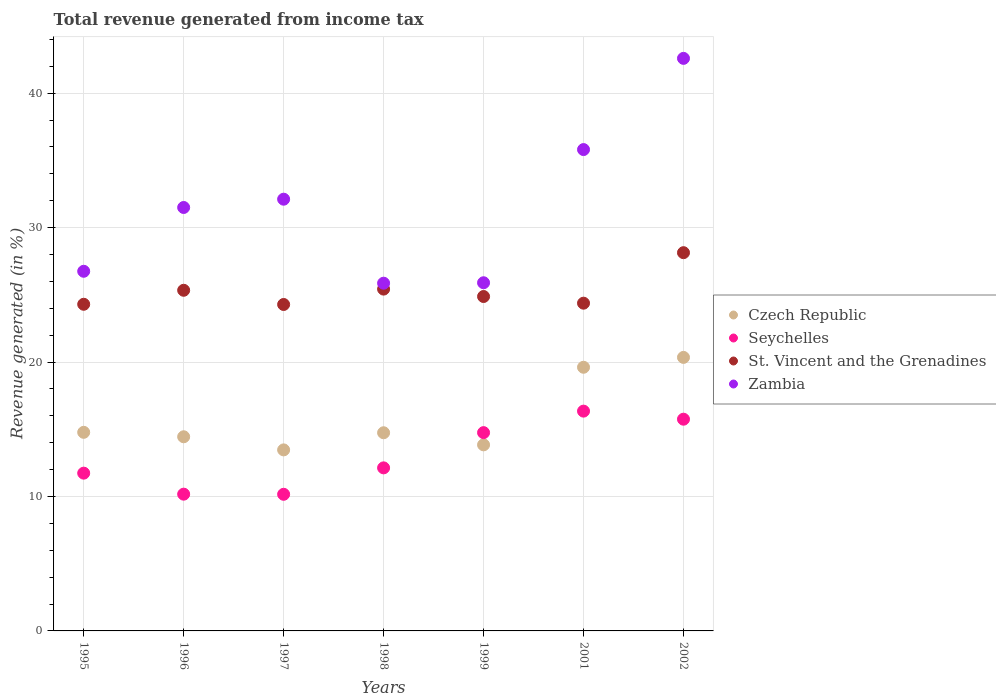Is the number of dotlines equal to the number of legend labels?
Your response must be concise. Yes. What is the total revenue generated in Seychelles in 1997?
Your response must be concise. 10.16. Across all years, what is the maximum total revenue generated in St. Vincent and the Grenadines?
Provide a succinct answer. 28.14. Across all years, what is the minimum total revenue generated in Czech Republic?
Provide a short and direct response. 13.47. In which year was the total revenue generated in Czech Republic minimum?
Your response must be concise. 1997. What is the total total revenue generated in Czech Republic in the graph?
Offer a very short reply. 111.23. What is the difference between the total revenue generated in Zambia in 1996 and that in 1997?
Provide a short and direct response. -0.62. What is the difference between the total revenue generated in Seychelles in 2001 and the total revenue generated in Zambia in 1996?
Make the answer very short. -15.15. What is the average total revenue generated in Seychelles per year?
Offer a very short reply. 13.01. In the year 1997, what is the difference between the total revenue generated in Seychelles and total revenue generated in Czech Republic?
Your answer should be very brief. -3.3. What is the ratio of the total revenue generated in Czech Republic in 1995 to that in 1996?
Your answer should be very brief. 1.02. What is the difference between the highest and the second highest total revenue generated in Seychelles?
Offer a very short reply. 0.6. What is the difference between the highest and the lowest total revenue generated in Zambia?
Offer a terse response. 16.72. In how many years, is the total revenue generated in Zambia greater than the average total revenue generated in Zambia taken over all years?
Your response must be concise. 3. Is it the case that in every year, the sum of the total revenue generated in St. Vincent and the Grenadines and total revenue generated in Seychelles  is greater than the sum of total revenue generated in Czech Republic and total revenue generated in Zambia?
Your response must be concise. Yes. Is it the case that in every year, the sum of the total revenue generated in St. Vincent and the Grenadines and total revenue generated in Czech Republic  is greater than the total revenue generated in Zambia?
Offer a terse response. Yes. Is the total revenue generated in St. Vincent and the Grenadines strictly greater than the total revenue generated in Seychelles over the years?
Your answer should be compact. Yes. Is the total revenue generated in Seychelles strictly less than the total revenue generated in Czech Republic over the years?
Your answer should be very brief. No. How many dotlines are there?
Your answer should be compact. 4. How many years are there in the graph?
Your answer should be very brief. 7. Where does the legend appear in the graph?
Your answer should be very brief. Center right. How many legend labels are there?
Your answer should be compact. 4. What is the title of the graph?
Provide a short and direct response. Total revenue generated from income tax. Does "Andorra" appear as one of the legend labels in the graph?
Your answer should be very brief. No. What is the label or title of the X-axis?
Offer a terse response. Years. What is the label or title of the Y-axis?
Give a very brief answer. Revenue generated (in %). What is the Revenue generated (in %) of Czech Republic in 1995?
Keep it short and to the point. 14.77. What is the Revenue generated (in %) in Seychelles in 1995?
Provide a short and direct response. 11.74. What is the Revenue generated (in %) of St. Vincent and the Grenadines in 1995?
Ensure brevity in your answer.  24.3. What is the Revenue generated (in %) in Zambia in 1995?
Offer a terse response. 26.75. What is the Revenue generated (in %) of Czech Republic in 1996?
Provide a succinct answer. 14.44. What is the Revenue generated (in %) in Seychelles in 1996?
Provide a succinct answer. 10.17. What is the Revenue generated (in %) in St. Vincent and the Grenadines in 1996?
Your answer should be very brief. 25.34. What is the Revenue generated (in %) in Zambia in 1996?
Provide a succinct answer. 31.5. What is the Revenue generated (in %) in Czech Republic in 1997?
Your answer should be compact. 13.47. What is the Revenue generated (in %) of Seychelles in 1997?
Offer a terse response. 10.16. What is the Revenue generated (in %) in St. Vincent and the Grenadines in 1997?
Ensure brevity in your answer.  24.28. What is the Revenue generated (in %) in Zambia in 1997?
Keep it short and to the point. 32.12. What is the Revenue generated (in %) in Czech Republic in 1998?
Offer a very short reply. 14.74. What is the Revenue generated (in %) of Seychelles in 1998?
Keep it short and to the point. 12.13. What is the Revenue generated (in %) of St. Vincent and the Grenadines in 1998?
Make the answer very short. 25.43. What is the Revenue generated (in %) in Zambia in 1998?
Keep it short and to the point. 25.87. What is the Revenue generated (in %) of Czech Republic in 1999?
Your answer should be compact. 13.84. What is the Revenue generated (in %) in Seychelles in 1999?
Give a very brief answer. 14.75. What is the Revenue generated (in %) of St. Vincent and the Grenadines in 1999?
Provide a succinct answer. 24.88. What is the Revenue generated (in %) of Zambia in 1999?
Your answer should be compact. 25.9. What is the Revenue generated (in %) in Czech Republic in 2001?
Offer a very short reply. 19.61. What is the Revenue generated (in %) of Seychelles in 2001?
Offer a terse response. 16.35. What is the Revenue generated (in %) of St. Vincent and the Grenadines in 2001?
Your answer should be very brief. 24.38. What is the Revenue generated (in %) in Zambia in 2001?
Provide a short and direct response. 35.81. What is the Revenue generated (in %) of Czech Republic in 2002?
Your answer should be very brief. 20.35. What is the Revenue generated (in %) in Seychelles in 2002?
Your response must be concise. 15.75. What is the Revenue generated (in %) of St. Vincent and the Grenadines in 2002?
Give a very brief answer. 28.14. What is the Revenue generated (in %) in Zambia in 2002?
Offer a very short reply. 42.59. Across all years, what is the maximum Revenue generated (in %) in Czech Republic?
Make the answer very short. 20.35. Across all years, what is the maximum Revenue generated (in %) in Seychelles?
Your answer should be compact. 16.35. Across all years, what is the maximum Revenue generated (in %) in St. Vincent and the Grenadines?
Make the answer very short. 28.14. Across all years, what is the maximum Revenue generated (in %) of Zambia?
Your response must be concise. 42.59. Across all years, what is the minimum Revenue generated (in %) of Czech Republic?
Ensure brevity in your answer.  13.47. Across all years, what is the minimum Revenue generated (in %) in Seychelles?
Your answer should be very brief. 10.16. Across all years, what is the minimum Revenue generated (in %) in St. Vincent and the Grenadines?
Your answer should be compact. 24.28. Across all years, what is the minimum Revenue generated (in %) in Zambia?
Your answer should be very brief. 25.87. What is the total Revenue generated (in %) of Czech Republic in the graph?
Keep it short and to the point. 111.23. What is the total Revenue generated (in %) of Seychelles in the graph?
Offer a very short reply. 91.05. What is the total Revenue generated (in %) in St. Vincent and the Grenadines in the graph?
Your answer should be compact. 176.74. What is the total Revenue generated (in %) of Zambia in the graph?
Offer a terse response. 220.53. What is the difference between the Revenue generated (in %) in Czech Republic in 1995 and that in 1996?
Your answer should be very brief. 0.33. What is the difference between the Revenue generated (in %) in Seychelles in 1995 and that in 1996?
Make the answer very short. 1.56. What is the difference between the Revenue generated (in %) of St. Vincent and the Grenadines in 1995 and that in 1996?
Your answer should be compact. -1.04. What is the difference between the Revenue generated (in %) of Zambia in 1995 and that in 1996?
Provide a short and direct response. -4.75. What is the difference between the Revenue generated (in %) of Czech Republic in 1995 and that in 1997?
Give a very brief answer. 1.31. What is the difference between the Revenue generated (in %) of Seychelles in 1995 and that in 1997?
Your answer should be compact. 1.57. What is the difference between the Revenue generated (in %) in St. Vincent and the Grenadines in 1995 and that in 1997?
Keep it short and to the point. 0.02. What is the difference between the Revenue generated (in %) of Zambia in 1995 and that in 1997?
Offer a terse response. -5.36. What is the difference between the Revenue generated (in %) of Czech Republic in 1995 and that in 1998?
Offer a terse response. 0.03. What is the difference between the Revenue generated (in %) in Seychelles in 1995 and that in 1998?
Your answer should be very brief. -0.39. What is the difference between the Revenue generated (in %) of St. Vincent and the Grenadines in 1995 and that in 1998?
Your answer should be very brief. -1.13. What is the difference between the Revenue generated (in %) in Zambia in 1995 and that in 1998?
Provide a short and direct response. 0.89. What is the difference between the Revenue generated (in %) of Czech Republic in 1995 and that in 1999?
Keep it short and to the point. 0.93. What is the difference between the Revenue generated (in %) in Seychelles in 1995 and that in 1999?
Keep it short and to the point. -3.01. What is the difference between the Revenue generated (in %) in St. Vincent and the Grenadines in 1995 and that in 1999?
Provide a short and direct response. -0.58. What is the difference between the Revenue generated (in %) of Zambia in 1995 and that in 1999?
Keep it short and to the point. 0.85. What is the difference between the Revenue generated (in %) in Czech Republic in 1995 and that in 2001?
Ensure brevity in your answer.  -4.84. What is the difference between the Revenue generated (in %) of Seychelles in 1995 and that in 2001?
Make the answer very short. -4.61. What is the difference between the Revenue generated (in %) in St. Vincent and the Grenadines in 1995 and that in 2001?
Ensure brevity in your answer.  -0.08. What is the difference between the Revenue generated (in %) in Zambia in 1995 and that in 2001?
Provide a short and direct response. -9.05. What is the difference between the Revenue generated (in %) of Czech Republic in 1995 and that in 2002?
Keep it short and to the point. -5.57. What is the difference between the Revenue generated (in %) of Seychelles in 1995 and that in 2002?
Ensure brevity in your answer.  -4.01. What is the difference between the Revenue generated (in %) of St. Vincent and the Grenadines in 1995 and that in 2002?
Offer a very short reply. -3.84. What is the difference between the Revenue generated (in %) in Zambia in 1995 and that in 2002?
Keep it short and to the point. -15.84. What is the difference between the Revenue generated (in %) in Czech Republic in 1996 and that in 1997?
Give a very brief answer. 0.98. What is the difference between the Revenue generated (in %) of Seychelles in 1996 and that in 1997?
Offer a terse response. 0.01. What is the difference between the Revenue generated (in %) in St. Vincent and the Grenadines in 1996 and that in 1997?
Keep it short and to the point. 1.06. What is the difference between the Revenue generated (in %) of Zambia in 1996 and that in 1997?
Offer a very short reply. -0.62. What is the difference between the Revenue generated (in %) in Czech Republic in 1996 and that in 1998?
Your response must be concise. -0.3. What is the difference between the Revenue generated (in %) of Seychelles in 1996 and that in 1998?
Offer a very short reply. -1.96. What is the difference between the Revenue generated (in %) of St. Vincent and the Grenadines in 1996 and that in 1998?
Make the answer very short. -0.09. What is the difference between the Revenue generated (in %) of Zambia in 1996 and that in 1998?
Your response must be concise. 5.63. What is the difference between the Revenue generated (in %) in Czech Republic in 1996 and that in 1999?
Offer a very short reply. 0.6. What is the difference between the Revenue generated (in %) in Seychelles in 1996 and that in 1999?
Provide a succinct answer. -4.58. What is the difference between the Revenue generated (in %) in St. Vincent and the Grenadines in 1996 and that in 1999?
Offer a terse response. 0.46. What is the difference between the Revenue generated (in %) in Zambia in 1996 and that in 1999?
Offer a terse response. 5.6. What is the difference between the Revenue generated (in %) in Czech Republic in 1996 and that in 2001?
Make the answer very short. -5.17. What is the difference between the Revenue generated (in %) of Seychelles in 1996 and that in 2001?
Provide a short and direct response. -6.18. What is the difference between the Revenue generated (in %) of St. Vincent and the Grenadines in 1996 and that in 2001?
Your response must be concise. 0.96. What is the difference between the Revenue generated (in %) of Zambia in 1996 and that in 2001?
Your answer should be very brief. -4.31. What is the difference between the Revenue generated (in %) in Czech Republic in 1996 and that in 2002?
Provide a short and direct response. -5.9. What is the difference between the Revenue generated (in %) in Seychelles in 1996 and that in 2002?
Keep it short and to the point. -5.58. What is the difference between the Revenue generated (in %) in St. Vincent and the Grenadines in 1996 and that in 2002?
Offer a very short reply. -2.8. What is the difference between the Revenue generated (in %) of Zambia in 1996 and that in 2002?
Provide a succinct answer. -11.09. What is the difference between the Revenue generated (in %) of Czech Republic in 1997 and that in 1998?
Your answer should be very brief. -1.27. What is the difference between the Revenue generated (in %) of Seychelles in 1997 and that in 1998?
Offer a very short reply. -1.97. What is the difference between the Revenue generated (in %) of St. Vincent and the Grenadines in 1997 and that in 1998?
Ensure brevity in your answer.  -1.14. What is the difference between the Revenue generated (in %) in Zambia in 1997 and that in 1998?
Your answer should be compact. 6.25. What is the difference between the Revenue generated (in %) of Czech Republic in 1997 and that in 1999?
Give a very brief answer. -0.38. What is the difference between the Revenue generated (in %) of Seychelles in 1997 and that in 1999?
Give a very brief answer. -4.59. What is the difference between the Revenue generated (in %) in St. Vincent and the Grenadines in 1997 and that in 1999?
Keep it short and to the point. -0.59. What is the difference between the Revenue generated (in %) in Zambia in 1997 and that in 1999?
Give a very brief answer. 6.22. What is the difference between the Revenue generated (in %) in Czech Republic in 1997 and that in 2001?
Offer a terse response. -6.15. What is the difference between the Revenue generated (in %) of Seychelles in 1997 and that in 2001?
Ensure brevity in your answer.  -6.19. What is the difference between the Revenue generated (in %) of St. Vincent and the Grenadines in 1997 and that in 2001?
Provide a succinct answer. -0.1. What is the difference between the Revenue generated (in %) in Zambia in 1997 and that in 2001?
Give a very brief answer. -3.69. What is the difference between the Revenue generated (in %) in Czech Republic in 1997 and that in 2002?
Your response must be concise. -6.88. What is the difference between the Revenue generated (in %) of Seychelles in 1997 and that in 2002?
Give a very brief answer. -5.59. What is the difference between the Revenue generated (in %) in St. Vincent and the Grenadines in 1997 and that in 2002?
Your answer should be very brief. -3.85. What is the difference between the Revenue generated (in %) in Zambia in 1997 and that in 2002?
Keep it short and to the point. -10.48. What is the difference between the Revenue generated (in %) of Czech Republic in 1998 and that in 1999?
Your answer should be compact. 0.9. What is the difference between the Revenue generated (in %) in Seychelles in 1998 and that in 1999?
Make the answer very short. -2.62. What is the difference between the Revenue generated (in %) of St. Vincent and the Grenadines in 1998 and that in 1999?
Your answer should be very brief. 0.55. What is the difference between the Revenue generated (in %) of Zambia in 1998 and that in 1999?
Give a very brief answer. -0.03. What is the difference between the Revenue generated (in %) in Czech Republic in 1998 and that in 2001?
Your answer should be very brief. -4.87. What is the difference between the Revenue generated (in %) in Seychelles in 1998 and that in 2001?
Give a very brief answer. -4.22. What is the difference between the Revenue generated (in %) in St. Vincent and the Grenadines in 1998 and that in 2001?
Offer a terse response. 1.05. What is the difference between the Revenue generated (in %) of Zambia in 1998 and that in 2001?
Your answer should be very brief. -9.94. What is the difference between the Revenue generated (in %) of Czech Republic in 1998 and that in 2002?
Provide a succinct answer. -5.61. What is the difference between the Revenue generated (in %) of Seychelles in 1998 and that in 2002?
Keep it short and to the point. -3.62. What is the difference between the Revenue generated (in %) of St. Vincent and the Grenadines in 1998 and that in 2002?
Offer a terse response. -2.71. What is the difference between the Revenue generated (in %) of Zambia in 1998 and that in 2002?
Your answer should be very brief. -16.72. What is the difference between the Revenue generated (in %) in Czech Republic in 1999 and that in 2001?
Offer a very short reply. -5.77. What is the difference between the Revenue generated (in %) of Seychelles in 1999 and that in 2001?
Provide a succinct answer. -1.6. What is the difference between the Revenue generated (in %) of St. Vincent and the Grenadines in 1999 and that in 2001?
Keep it short and to the point. 0.5. What is the difference between the Revenue generated (in %) of Zambia in 1999 and that in 2001?
Provide a short and direct response. -9.91. What is the difference between the Revenue generated (in %) of Czech Republic in 1999 and that in 2002?
Your response must be concise. -6.5. What is the difference between the Revenue generated (in %) in Seychelles in 1999 and that in 2002?
Provide a short and direct response. -1. What is the difference between the Revenue generated (in %) in St. Vincent and the Grenadines in 1999 and that in 2002?
Offer a terse response. -3.26. What is the difference between the Revenue generated (in %) of Zambia in 1999 and that in 2002?
Ensure brevity in your answer.  -16.69. What is the difference between the Revenue generated (in %) in Czech Republic in 2001 and that in 2002?
Your answer should be very brief. -0.73. What is the difference between the Revenue generated (in %) of Seychelles in 2001 and that in 2002?
Your answer should be very brief. 0.6. What is the difference between the Revenue generated (in %) in St. Vincent and the Grenadines in 2001 and that in 2002?
Your answer should be very brief. -3.76. What is the difference between the Revenue generated (in %) of Zambia in 2001 and that in 2002?
Offer a terse response. -6.78. What is the difference between the Revenue generated (in %) of Czech Republic in 1995 and the Revenue generated (in %) of Seychelles in 1996?
Your answer should be very brief. 4.6. What is the difference between the Revenue generated (in %) in Czech Republic in 1995 and the Revenue generated (in %) in St. Vincent and the Grenadines in 1996?
Offer a terse response. -10.57. What is the difference between the Revenue generated (in %) of Czech Republic in 1995 and the Revenue generated (in %) of Zambia in 1996?
Ensure brevity in your answer.  -16.73. What is the difference between the Revenue generated (in %) of Seychelles in 1995 and the Revenue generated (in %) of St. Vincent and the Grenadines in 1996?
Make the answer very short. -13.6. What is the difference between the Revenue generated (in %) in Seychelles in 1995 and the Revenue generated (in %) in Zambia in 1996?
Your response must be concise. -19.76. What is the difference between the Revenue generated (in %) of Czech Republic in 1995 and the Revenue generated (in %) of Seychelles in 1997?
Your response must be concise. 4.61. What is the difference between the Revenue generated (in %) of Czech Republic in 1995 and the Revenue generated (in %) of St. Vincent and the Grenadines in 1997?
Your answer should be very brief. -9.51. What is the difference between the Revenue generated (in %) in Czech Republic in 1995 and the Revenue generated (in %) in Zambia in 1997?
Offer a very short reply. -17.34. What is the difference between the Revenue generated (in %) in Seychelles in 1995 and the Revenue generated (in %) in St. Vincent and the Grenadines in 1997?
Ensure brevity in your answer.  -12.55. What is the difference between the Revenue generated (in %) in Seychelles in 1995 and the Revenue generated (in %) in Zambia in 1997?
Your answer should be very brief. -20.38. What is the difference between the Revenue generated (in %) of St. Vincent and the Grenadines in 1995 and the Revenue generated (in %) of Zambia in 1997?
Make the answer very short. -7.82. What is the difference between the Revenue generated (in %) of Czech Republic in 1995 and the Revenue generated (in %) of Seychelles in 1998?
Provide a short and direct response. 2.64. What is the difference between the Revenue generated (in %) in Czech Republic in 1995 and the Revenue generated (in %) in St. Vincent and the Grenadines in 1998?
Offer a terse response. -10.65. What is the difference between the Revenue generated (in %) in Czech Republic in 1995 and the Revenue generated (in %) in Zambia in 1998?
Your response must be concise. -11.09. What is the difference between the Revenue generated (in %) of Seychelles in 1995 and the Revenue generated (in %) of St. Vincent and the Grenadines in 1998?
Offer a terse response. -13.69. What is the difference between the Revenue generated (in %) of Seychelles in 1995 and the Revenue generated (in %) of Zambia in 1998?
Your response must be concise. -14.13. What is the difference between the Revenue generated (in %) of St. Vincent and the Grenadines in 1995 and the Revenue generated (in %) of Zambia in 1998?
Make the answer very short. -1.57. What is the difference between the Revenue generated (in %) of Czech Republic in 1995 and the Revenue generated (in %) of Seychelles in 1999?
Ensure brevity in your answer.  0.02. What is the difference between the Revenue generated (in %) in Czech Republic in 1995 and the Revenue generated (in %) in St. Vincent and the Grenadines in 1999?
Ensure brevity in your answer.  -10.1. What is the difference between the Revenue generated (in %) in Czech Republic in 1995 and the Revenue generated (in %) in Zambia in 1999?
Provide a short and direct response. -11.13. What is the difference between the Revenue generated (in %) in Seychelles in 1995 and the Revenue generated (in %) in St. Vincent and the Grenadines in 1999?
Offer a terse response. -13.14. What is the difference between the Revenue generated (in %) of Seychelles in 1995 and the Revenue generated (in %) of Zambia in 1999?
Offer a terse response. -14.16. What is the difference between the Revenue generated (in %) in St. Vincent and the Grenadines in 1995 and the Revenue generated (in %) in Zambia in 1999?
Provide a succinct answer. -1.6. What is the difference between the Revenue generated (in %) of Czech Republic in 1995 and the Revenue generated (in %) of Seychelles in 2001?
Ensure brevity in your answer.  -1.58. What is the difference between the Revenue generated (in %) in Czech Republic in 1995 and the Revenue generated (in %) in St. Vincent and the Grenadines in 2001?
Give a very brief answer. -9.61. What is the difference between the Revenue generated (in %) in Czech Republic in 1995 and the Revenue generated (in %) in Zambia in 2001?
Give a very brief answer. -21.03. What is the difference between the Revenue generated (in %) of Seychelles in 1995 and the Revenue generated (in %) of St. Vincent and the Grenadines in 2001?
Provide a succinct answer. -12.64. What is the difference between the Revenue generated (in %) of Seychelles in 1995 and the Revenue generated (in %) of Zambia in 2001?
Your answer should be compact. -24.07. What is the difference between the Revenue generated (in %) in St. Vincent and the Grenadines in 1995 and the Revenue generated (in %) in Zambia in 2001?
Offer a very short reply. -11.51. What is the difference between the Revenue generated (in %) in Czech Republic in 1995 and the Revenue generated (in %) in Seychelles in 2002?
Your response must be concise. -0.98. What is the difference between the Revenue generated (in %) in Czech Republic in 1995 and the Revenue generated (in %) in St. Vincent and the Grenadines in 2002?
Your answer should be very brief. -13.36. What is the difference between the Revenue generated (in %) of Czech Republic in 1995 and the Revenue generated (in %) of Zambia in 2002?
Provide a succinct answer. -27.82. What is the difference between the Revenue generated (in %) of Seychelles in 1995 and the Revenue generated (in %) of St. Vincent and the Grenadines in 2002?
Give a very brief answer. -16.4. What is the difference between the Revenue generated (in %) of Seychelles in 1995 and the Revenue generated (in %) of Zambia in 2002?
Provide a succinct answer. -30.86. What is the difference between the Revenue generated (in %) in St. Vincent and the Grenadines in 1995 and the Revenue generated (in %) in Zambia in 2002?
Your answer should be very brief. -18.29. What is the difference between the Revenue generated (in %) of Czech Republic in 1996 and the Revenue generated (in %) of Seychelles in 1997?
Give a very brief answer. 4.28. What is the difference between the Revenue generated (in %) in Czech Republic in 1996 and the Revenue generated (in %) in St. Vincent and the Grenadines in 1997?
Provide a succinct answer. -9.84. What is the difference between the Revenue generated (in %) in Czech Republic in 1996 and the Revenue generated (in %) in Zambia in 1997?
Provide a succinct answer. -17.67. What is the difference between the Revenue generated (in %) in Seychelles in 1996 and the Revenue generated (in %) in St. Vincent and the Grenadines in 1997?
Offer a very short reply. -14.11. What is the difference between the Revenue generated (in %) of Seychelles in 1996 and the Revenue generated (in %) of Zambia in 1997?
Keep it short and to the point. -21.94. What is the difference between the Revenue generated (in %) of St. Vincent and the Grenadines in 1996 and the Revenue generated (in %) of Zambia in 1997?
Your response must be concise. -6.78. What is the difference between the Revenue generated (in %) in Czech Republic in 1996 and the Revenue generated (in %) in Seychelles in 1998?
Provide a succinct answer. 2.31. What is the difference between the Revenue generated (in %) in Czech Republic in 1996 and the Revenue generated (in %) in St. Vincent and the Grenadines in 1998?
Make the answer very short. -10.98. What is the difference between the Revenue generated (in %) in Czech Republic in 1996 and the Revenue generated (in %) in Zambia in 1998?
Your answer should be compact. -11.42. What is the difference between the Revenue generated (in %) in Seychelles in 1996 and the Revenue generated (in %) in St. Vincent and the Grenadines in 1998?
Your answer should be compact. -15.25. What is the difference between the Revenue generated (in %) of Seychelles in 1996 and the Revenue generated (in %) of Zambia in 1998?
Your answer should be very brief. -15.69. What is the difference between the Revenue generated (in %) in St. Vincent and the Grenadines in 1996 and the Revenue generated (in %) in Zambia in 1998?
Give a very brief answer. -0.53. What is the difference between the Revenue generated (in %) of Czech Republic in 1996 and the Revenue generated (in %) of Seychelles in 1999?
Offer a very short reply. -0.31. What is the difference between the Revenue generated (in %) in Czech Republic in 1996 and the Revenue generated (in %) in St. Vincent and the Grenadines in 1999?
Your response must be concise. -10.43. What is the difference between the Revenue generated (in %) in Czech Republic in 1996 and the Revenue generated (in %) in Zambia in 1999?
Your answer should be compact. -11.46. What is the difference between the Revenue generated (in %) of Seychelles in 1996 and the Revenue generated (in %) of St. Vincent and the Grenadines in 1999?
Offer a very short reply. -14.7. What is the difference between the Revenue generated (in %) of Seychelles in 1996 and the Revenue generated (in %) of Zambia in 1999?
Offer a very short reply. -15.73. What is the difference between the Revenue generated (in %) of St. Vincent and the Grenadines in 1996 and the Revenue generated (in %) of Zambia in 1999?
Give a very brief answer. -0.56. What is the difference between the Revenue generated (in %) in Czech Republic in 1996 and the Revenue generated (in %) in Seychelles in 2001?
Make the answer very short. -1.91. What is the difference between the Revenue generated (in %) of Czech Republic in 1996 and the Revenue generated (in %) of St. Vincent and the Grenadines in 2001?
Provide a succinct answer. -9.94. What is the difference between the Revenue generated (in %) in Czech Republic in 1996 and the Revenue generated (in %) in Zambia in 2001?
Your answer should be compact. -21.36. What is the difference between the Revenue generated (in %) of Seychelles in 1996 and the Revenue generated (in %) of St. Vincent and the Grenadines in 2001?
Keep it short and to the point. -14.21. What is the difference between the Revenue generated (in %) of Seychelles in 1996 and the Revenue generated (in %) of Zambia in 2001?
Provide a short and direct response. -25.63. What is the difference between the Revenue generated (in %) in St. Vincent and the Grenadines in 1996 and the Revenue generated (in %) in Zambia in 2001?
Offer a terse response. -10.47. What is the difference between the Revenue generated (in %) in Czech Republic in 1996 and the Revenue generated (in %) in Seychelles in 2002?
Your response must be concise. -1.31. What is the difference between the Revenue generated (in %) of Czech Republic in 1996 and the Revenue generated (in %) of St. Vincent and the Grenadines in 2002?
Give a very brief answer. -13.69. What is the difference between the Revenue generated (in %) of Czech Republic in 1996 and the Revenue generated (in %) of Zambia in 2002?
Your response must be concise. -28.15. What is the difference between the Revenue generated (in %) of Seychelles in 1996 and the Revenue generated (in %) of St. Vincent and the Grenadines in 2002?
Provide a short and direct response. -17.96. What is the difference between the Revenue generated (in %) of Seychelles in 1996 and the Revenue generated (in %) of Zambia in 2002?
Provide a short and direct response. -32.42. What is the difference between the Revenue generated (in %) in St. Vincent and the Grenadines in 1996 and the Revenue generated (in %) in Zambia in 2002?
Your answer should be very brief. -17.25. What is the difference between the Revenue generated (in %) in Czech Republic in 1997 and the Revenue generated (in %) in Seychelles in 1998?
Provide a succinct answer. 1.34. What is the difference between the Revenue generated (in %) of Czech Republic in 1997 and the Revenue generated (in %) of St. Vincent and the Grenadines in 1998?
Offer a very short reply. -11.96. What is the difference between the Revenue generated (in %) of Czech Republic in 1997 and the Revenue generated (in %) of Zambia in 1998?
Ensure brevity in your answer.  -12.4. What is the difference between the Revenue generated (in %) in Seychelles in 1997 and the Revenue generated (in %) in St. Vincent and the Grenadines in 1998?
Offer a very short reply. -15.26. What is the difference between the Revenue generated (in %) in Seychelles in 1997 and the Revenue generated (in %) in Zambia in 1998?
Your response must be concise. -15.7. What is the difference between the Revenue generated (in %) in St. Vincent and the Grenadines in 1997 and the Revenue generated (in %) in Zambia in 1998?
Provide a succinct answer. -1.58. What is the difference between the Revenue generated (in %) in Czech Republic in 1997 and the Revenue generated (in %) in Seychelles in 1999?
Provide a short and direct response. -1.28. What is the difference between the Revenue generated (in %) of Czech Republic in 1997 and the Revenue generated (in %) of St. Vincent and the Grenadines in 1999?
Your answer should be compact. -11.41. What is the difference between the Revenue generated (in %) of Czech Republic in 1997 and the Revenue generated (in %) of Zambia in 1999?
Provide a short and direct response. -12.43. What is the difference between the Revenue generated (in %) of Seychelles in 1997 and the Revenue generated (in %) of St. Vincent and the Grenadines in 1999?
Provide a short and direct response. -14.71. What is the difference between the Revenue generated (in %) of Seychelles in 1997 and the Revenue generated (in %) of Zambia in 1999?
Your answer should be very brief. -15.74. What is the difference between the Revenue generated (in %) in St. Vincent and the Grenadines in 1997 and the Revenue generated (in %) in Zambia in 1999?
Your answer should be very brief. -1.62. What is the difference between the Revenue generated (in %) in Czech Republic in 1997 and the Revenue generated (in %) in Seychelles in 2001?
Keep it short and to the point. -2.88. What is the difference between the Revenue generated (in %) in Czech Republic in 1997 and the Revenue generated (in %) in St. Vincent and the Grenadines in 2001?
Offer a terse response. -10.91. What is the difference between the Revenue generated (in %) of Czech Republic in 1997 and the Revenue generated (in %) of Zambia in 2001?
Your answer should be compact. -22.34. What is the difference between the Revenue generated (in %) of Seychelles in 1997 and the Revenue generated (in %) of St. Vincent and the Grenadines in 2001?
Your response must be concise. -14.22. What is the difference between the Revenue generated (in %) of Seychelles in 1997 and the Revenue generated (in %) of Zambia in 2001?
Your response must be concise. -25.64. What is the difference between the Revenue generated (in %) in St. Vincent and the Grenadines in 1997 and the Revenue generated (in %) in Zambia in 2001?
Your answer should be very brief. -11.52. What is the difference between the Revenue generated (in %) in Czech Republic in 1997 and the Revenue generated (in %) in Seychelles in 2002?
Offer a terse response. -2.28. What is the difference between the Revenue generated (in %) in Czech Republic in 1997 and the Revenue generated (in %) in St. Vincent and the Grenadines in 2002?
Offer a terse response. -14.67. What is the difference between the Revenue generated (in %) in Czech Republic in 1997 and the Revenue generated (in %) in Zambia in 2002?
Keep it short and to the point. -29.12. What is the difference between the Revenue generated (in %) of Seychelles in 1997 and the Revenue generated (in %) of St. Vincent and the Grenadines in 2002?
Keep it short and to the point. -17.97. What is the difference between the Revenue generated (in %) in Seychelles in 1997 and the Revenue generated (in %) in Zambia in 2002?
Provide a succinct answer. -32.43. What is the difference between the Revenue generated (in %) of St. Vincent and the Grenadines in 1997 and the Revenue generated (in %) of Zambia in 2002?
Your answer should be compact. -18.31. What is the difference between the Revenue generated (in %) of Czech Republic in 1998 and the Revenue generated (in %) of Seychelles in 1999?
Ensure brevity in your answer.  -0.01. What is the difference between the Revenue generated (in %) in Czech Republic in 1998 and the Revenue generated (in %) in St. Vincent and the Grenadines in 1999?
Your answer should be very brief. -10.14. What is the difference between the Revenue generated (in %) in Czech Republic in 1998 and the Revenue generated (in %) in Zambia in 1999?
Keep it short and to the point. -11.16. What is the difference between the Revenue generated (in %) in Seychelles in 1998 and the Revenue generated (in %) in St. Vincent and the Grenadines in 1999?
Offer a very short reply. -12.75. What is the difference between the Revenue generated (in %) of Seychelles in 1998 and the Revenue generated (in %) of Zambia in 1999?
Your answer should be compact. -13.77. What is the difference between the Revenue generated (in %) of St. Vincent and the Grenadines in 1998 and the Revenue generated (in %) of Zambia in 1999?
Offer a terse response. -0.47. What is the difference between the Revenue generated (in %) of Czech Republic in 1998 and the Revenue generated (in %) of Seychelles in 2001?
Ensure brevity in your answer.  -1.61. What is the difference between the Revenue generated (in %) of Czech Republic in 1998 and the Revenue generated (in %) of St. Vincent and the Grenadines in 2001?
Keep it short and to the point. -9.64. What is the difference between the Revenue generated (in %) in Czech Republic in 1998 and the Revenue generated (in %) in Zambia in 2001?
Offer a terse response. -21.07. What is the difference between the Revenue generated (in %) in Seychelles in 1998 and the Revenue generated (in %) in St. Vincent and the Grenadines in 2001?
Give a very brief answer. -12.25. What is the difference between the Revenue generated (in %) in Seychelles in 1998 and the Revenue generated (in %) in Zambia in 2001?
Your response must be concise. -23.68. What is the difference between the Revenue generated (in %) of St. Vincent and the Grenadines in 1998 and the Revenue generated (in %) of Zambia in 2001?
Your answer should be very brief. -10.38. What is the difference between the Revenue generated (in %) of Czech Republic in 1998 and the Revenue generated (in %) of Seychelles in 2002?
Your response must be concise. -1.01. What is the difference between the Revenue generated (in %) of Czech Republic in 1998 and the Revenue generated (in %) of St. Vincent and the Grenadines in 2002?
Your response must be concise. -13.4. What is the difference between the Revenue generated (in %) in Czech Republic in 1998 and the Revenue generated (in %) in Zambia in 2002?
Keep it short and to the point. -27.85. What is the difference between the Revenue generated (in %) of Seychelles in 1998 and the Revenue generated (in %) of St. Vincent and the Grenadines in 2002?
Ensure brevity in your answer.  -16.01. What is the difference between the Revenue generated (in %) in Seychelles in 1998 and the Revenue generated (in %) in Zambia in 2002?
Ensure brevity in your answer.  -30.46. What is the difference between the Revenue generated (in %) of St. Vincent and the Grenadines in 1998 and the Revenue generated (in %) of Zambia in 2002?
Offer a terse response. -17.16. What is the difference between the Revenue generated (in %) in Czech Republic in 1999 and the Revenue generated (in %) in Seychelles in 2001?
Your response must be concise. -2.51. What is the difference between the Revenue generated (in %) of Czech Republic in 1999 and the Revenue generated (in %) of St. Vincent and the Grenadines in 2001?
Provide a succinct answer. -10.54. What is the difference between the Revenue generated (in %) in Czech Republic in 1999 and the Revenue generated (in %) in Zambia in 2001?
Keep it short and to the point. -21.96. What is the difference between the Revenue generated (in %) of Seychelles in 1999 and the Revenue generated (in %) of St. Vincent and the Grenadines in 2001?
Provide a short and direct response. -9.63. What is the difference between the Revenue generated (in %) in Seychelles in 1999 and the Revenue generated (in %) in Zambia in 2001?
Offer a very short reply. -21.06. What is the difference between the Revenue generated (in %) of St. Vincent and the Grenadines in 1999 and the Revenue generated (in %) of Zambia in 2001?
Offer a very short reply. -10.93. What is the difference between the Revenue generated (in %) in Czech Republic in 1999 and the Revenue generated (in %) in Seychelles in 2002?
Provide a succinct answer. -1.91. What is the difference between the Revenue generated (in %) of Czech Republic in 1999 and the Revenue generated (in %) of St. Vincent and the Grenadines in 2002?
Keep it short and to the point. -14.29. What is the difference between the Revenue generated (in %) of Czech Republic in 1999 and the Revenue generated (in %) of Zambia in 2002?
Provide a short and direct response. -28.75. What is the difference between the Revenue generated (in %) of Seychelles in 1999 and the Revenue generated (in %) of St. Vincent and the Grenadines in 2002?
Provide a succinct answer. -13.39. What is the difference between the Revenue generated (in %) in Seychelles in 1999 and the Revenue generated (in %) in Zambia in 2002?
Provide a succinct answer. -27.84. What is the difference between the Revenue generated (in %) in St. Vincent and the Grenadines in 1999 and the Revenue generated (in %) in Zambia in 2002?
Your response must be concise. -17.71. What is the difference between the Revenue generated (in %) in Czech Republic in 2001 and the Revenue generated (in %) in Seychelles in 2002?
Give a very brief answer. 3.86. What is the difference between the Revenue generated (in %) of Czech Republic in 2001 and the Revenue generated (in %) of St. Vincent and the Grenadines in 2002?
Give a very brief answer. -8.52. What is the difference between the Revenue generated (in %) of Czech Republic in 2001 and the Revenue generated (in %) of Zambia in 2002?
Provide a succinct answer. -22.98. What is the difference between the Revenue generated (in %) of Seychelles in 2001 and the Revenue generated (in %) of St. Vincent and the Grenadines in 2002?
Give a very brief answer. -11.79. What is the difference between the Revenue generated (in %) in Seychelles in 2001 and the Revenue generated (in %) in Zambia in 2002?
Offer a terse response. -26.24. What is the difference between the Revenue generated (in %) in St. Vincent and the Grenadines in 2001 and the Revenue generated (in %) in Zambia in 2002?
Make the answer very short. -18.21. What is the average Revenue generated (in %) in Czech Republic per year?
Make the answer very short. 15.89. What is the average Revenue generated (in %) in Seychelles per year?
Give a very brief answer. 13.01. What is the average Revenue generated (in %) in St. Vincent and the Grenadines per year?
Provide a succinct answer. 25.25. What is the average Revenue generated (in %) in Zambia per year?
Provide a succinct answer. 31.5. In the year 1995, what is the difference between the Revenue generated (in %) in Czech Republic and Revenue generated (in %) in Seychelles?
Your response must be concise. 3.04. In the year 1995, what is the difference between the Revenue generated (in %) in Czech Republic and Revenue generated (in %) in St. Vincent and the Grenadines?
Provide a succinct answer. -9.53. In the year 1995, what is the difference between the Revenue generated (in %) of Czech Republic and Revenue generated (in %) of Zambia?
Offer a terse response. -11.98. In the year 1995, what is the difference between the Revenue generated (in %) of Seychelles and Revenue generated (in %) of St. Vincent and the Grenadines?
Offer a terse response. -12.56. In the year 1995, what is the difference between the Revenue generated (in %) in Seychelles and Revenue generated (in %) in Zambia?
Your response must be concise. -15.02. In the year 1995, what is the difference between the Revenue generated (in %) of St. Vincent and the Grenadines and Revenue generated (in %) of Zambia?
Your response must be concise. -2.45. In the year 1996, what is the difference between the Revenue generated (in %) of Czech Republic and Revenue generated (in %) of Seychelles?
Your answer should be compact. 4.27. In the year 1996, what is the difference between the Revenue generated (in %) in Czech Republic and Revenue generated (in %) in St. Vincent and the Grenadines?
Offer a very short reply. -10.9. In the year 1996, what is the difference between the Revenue generated (in %) of Czech Republic and Revenue generated (in %) of Zambia?
Your answer should be very brief. -17.06. In the year 1996, what is the difference between the Revenue generated (in %) in Seychelles and Revenue generated (in %) in St. Vincent and the Grenadines?
Your response must be concise. -15.17. In the year 1996, what is the difference between the Revenue generated (in %) in Seychelles and Revenue generated (in %) in Zambia?
Make the answer very short. -21.33. In the year 1996, what is the difference between the Revenue generated (in %) in St. Vincent and the Grenadines and Revenue generated (in %) in Zambia?
Your response must be concise. -6.16. In the year 1997, what is the difference between the Revenue generated (in %) in Czech Republic and Revenue generated (in %) in Seychelles?
Offer a very short reply. 3.3. In the year 1997, what is the difference between the Revenue generated (in %) of Czech Republic and Revenue generated (in %) of St. Vincent and the Grenadines?
Your response must be concise. -10.82. In the year 1997, what is the difference between the Revenue generated (in %) of Czech Republic and Revenue generated (in %) of Zambia?
Offer a very short reply. -18.65. In the year 1997, what is the difference between the Revenue generated (in %) in Seychelles and Revenue generated (in %) in St. Vincent and the Grenadines?
Offer a very short reply. -14.12. In the year 1997, what is the difference between the Revenue generated (in %) in Seychelles and Revenue generated (in %) in Zambia?
Keep it short and to the point. -21.95. In the year 1997, what is the difference between the Revenue generated (in %) in St. Vincent and the Grenadines and Revenue generated (in %) in Zambia?
Give a very brief answer. -7.83. In the year 1998, what is the difference between the Revenue generated (in %) in Czech Republic and Revenue generated (in %) in Seychelles?
Your answer should be very brief. 2.61. In the year 1998, what is the difference between the Revenue generated (in %) of Czech Republic and Revenue generated (in %) of St. Vincent and the Grenadines?
Provide a short and direct response. -10.69. In the year 1998, what is the difference between the Revenue generated (in %) of Czech Republic and Revenue generated (in %) of Zambia?
Offer a very short reply. -11.13. In the year 1998, what is the difference between the Revenue generated (in %) of Seychelles and Revenue generated (in %) of St. Vincent and the Grenadines?
Provide a short and direct response. -13.3. In the year 1998, what is the difference between the Revenue generated (in %) of Seychelles and Revenue generated (in %) of Zambia?
Provide a short and direct response. -13.74. In the year 1998, what is the difference between the Revenue generated (in %) in St. Vincent and the Grenadines and Revenue generated (in %) in Zambia?
Your answer should be very brief. -0.44. In the year 1999, what is the difference between the Revenue generated (in %) of Czech Republic and Revenue generated (in %) of Seychelles?
Make the answer very short. -0.91. In the year 1999, what is the difference between the Revenue generated (in %) in Czech Republic and Revenue generated (in %) in St. Vincent and the Grenadines?
Offer a terse response. -11.03. In the year 1999, what is the difference between the Revenue generated (in %) of Czech Republic and Revenue generated (in %) of Zambia?
Give a very brief answer. -12.06. In the year 1999, what is the difference between the Revenue generated (in %) in Seychelles and Revenue generated (in %) in St. Vincent and the Grenadines?
Your answer should be very brief. -10.13. In the year 1999, what is the difference between the Revenue generated (in %) of Seychelles and Revenue generated (in %) of Zambia?
Ensure brevity in your answer.  -11.15. In the year 1999, what is the difference between the Revenue generated (in %) in St. Vincent and the Grenadines and Revenue generated (in %) in Zambia?
Offer a very short reply. -1.02. In the year 2001, what is the difference between the Revenue generated (in %) of Czech Republic and Revenue generated (in %) of Seychelles?
Make the answer very short. 3.26. In the year 2001, what is the difference between the Revenue generated (in %) of Czech Republic and Revenue generated (in %) of St. Vincent and the Grenadines?
Offer a terse response. -4.77. In the year 2001, what is the difference between the Revenue generated (in %) in Czech Republic and Revenue generated (in %) in Zambia?
Your answer should be compact. -16.19. In the year 2001, what is the difference between the Revenue generated (in %) of Seychelles and Revenue generated (in %) of St. Vincent and the Grenadines?
Offer a terse response. -8.03. In the year 2001, what is the difference between the Revenue generated (in %) of Seychelles and Revenue generated (in %) of Zambia?
Offer a terse response. -19.46. In the year 2001, what is the difference between the Revenue generated (in %) of St. Vincent and the Grenadines and Revenue generated (in %) of Zambia?
Provide a short and direct response. -11.43. In the year 2002, what is the difference between the Revenue generated (in %) in Czech Republic and Revenue generated (in %) in Seychelles?
Keep it short and to the point. 4.6. In the year 2002, what is the difference between the Revenue generated (in %) of Czech Republic and Revenue generated (in %) of St. Vincent and the Grenadines?
Your response must be concise. -7.79. In the year 2002, what is the difference between the Revenue generated (in %) of Czech Republic and Revenue generated (in %) of Zambia?
Give a very brief answer. -22.24. In the year 2002, what is the difference between the Revenue generated (in %) of Seychelles and Revenue generated (in %) of St. Vincent and the Grenadines?
Your answer should be very brief. -12.39. In the year 2002, what is the difference between the Revenue generated (in %) in Seychelles and Revenue generated (in %) in Zambia?
Your answer should be very brief. -26.84. In the year 2002, what is the difference between the Revenue generated (in %) in St. Vincent and the Grenadines and Revenue generated (in %) in Zambia?
Your answer should be compact. -14.45. What is the ratio of the Revenue generated (in %) of Czech Republic in 1995 to that in 1996?
Keep it short and to the point. 1.02. What is the ratio of the Revenue generated (in %) of Seychelles in 1995 to that in 1996?
Provide a succinct answer. 1.15. What is the ratio of the Revenue generated (in %) of St. Vincent and the Grenadines in 1995 to that in 1996?
Make the answer very short. 0.96. What is the ratio of the Revenue generated (in %) of Zambia in 1995 to that in 1996?
Your answer should be very brief. 0.85. What is the ratio of the Revenue generated (in %) of Czech Republic in 1995 to that in 1997?
Your answer should be very brief. 1.1. What is the ratio of the Revenue generated (in %) in Seychelles in 1995 to that in 1997?
Your answer should be compact. 1.15. What is the ratio of the Revenue generated (in %) of Zambia in 1995 to that in 1997?
Offer a terse response. 0.83. What is the ratio of the Revenue generated (in %) in Czech Republic in 1995 to that in 1998?
Give a very brief answer. 1. What is the ratio of the Revenue generated (in %) of Seychelles in 1995 to that in 1998?
Offer a very short reply. 0.97. What is the ratio of the Revenue generated (in %) of St. Vincent and the Grenadines in 1995 to that in 1998?
Your answer should be very brief. 0.96. What is the ratio of the Revenue generated (in %) in Zambia in 1995 to that in 1998?
Provide a succinct answer. 1.03. What is the ratio of the Revenue generated (in %) of Czech Republic in 1995 to that in 1999?
Keep it short and to the point. 1.07. What is the ratio of the Revenue generated (in %) in Seychelles in 1995 to that in 1999?
Offer a very short reply. 0.8. What is the ratio of the Revenue generated (in %) of St. Vincent and the Grenadines in 1995 to that in 1999?
Ensure brevity in your answer.  0.98. What is the ratio of the Revenue generated (in %) of Zambia in 1995 to that in 1999?
Offer a terse response. 1.03. What is the ratio of the Revenue generated (in %) of Czech Republic in 1995 to that in 2001?
Your answer should be compact. 0.75. What is the ratio of the Revenue generated (in %) in Seychelles in 1995 to that in 2001?
Provide a short and direct response. 0.72. What is the ratio of the Revenue generated (in %) in St. Vincent and the Grenadines in 1995 to that in 2001?
Your response must be concise. 1. What is the ratio of the Revenue generated (in %) in Zambia in 1995 to that in 2001?
Provide a succinct answer. 0.75. What is the ratio of the Revenue generated (in %) in Czech Republic in 1995 to that in 2002?
Make the answer very short. 0.73. What is the ratio of the Revenue generated (in %) of Seychelles in 1995 to that in 2002?
Keep it short and to the point. 0.75. What is the ratio of the Revenue generated (in %) of St. Vincent and the Grenadines in 1995 to that in 2002?
Your answer should be very brief. 0.86. What is the ratio of the Revenue generated (in %) in Zambia in 1995 to that in 2002?
Your response must be concise. 0.63. What is the ratio of the Revenue generated (in %) in Czech Republic in 1996 to that in 1997?
Make the answer very short. 1.07. What is the ratio of the Revenue generated (in %) in Seychelles in 1996 to that in 1997?
Keep it short and to the point. 1. What is the ratio of the Revenue generated (in %) in St. Vincent and the Grenadines in 1996 to that in 1997?
Your answer should be compact. 1.04. What is the ratio of the Revenue generated (in %) of Zambia in 1996 to that in 1997?
Ensure brevity in your answer.  0.98. What is the ratio of the Revenue generated (in %) of Czech Republic in 1996 to that in 1998?
Your response must be concise. 0.98. What is the ratio of the Revenue generated (in %) of Seychelles in 1996 to that in 1998?
Give a very brief answer. 0.84. What is the ratio of the Revenue generated (in %) of Zambia in 1996 to that in 1998?
Your response must be concise. 1.22. What is the ratio of the Revenue generated (in %) in Czech Republic in 1996 to that in 1999?
Keep it short and to the point. 1.04. What is the ratio of the Revenue generated (in %) of Seychelles in 1996 to that in 1999?
Keep it short and to the point. 0.69. What is the ratio of the Revenue generated (in %) in St. Vincent and the Grenadines in 1996 to that in 1999?
Your answer should be compact. 1.02. What is the ratio of the Revenue generated (in %) of Zambia in 1996 to that in 1999?
Your response must be concise. 1.22. What is the ratio of the Revenue generated (in %) in Czech Republic in 1996 to that in 2001?
Provide a succinct answer. 0.74. What is the ratio of the Revenue generated (in %) of Seychelles in 1996 to that in 2001?
Keep it short and to the point. 0.62. What is the ratio of the Revenue generated (in %) of St. Vincent and the Grenadines in 1996 to that in 2001?
Give a very brief answer. 1.04. What is the ratio of the Revenue generated (in %) of Zambia in 1996 to that in 2001?
Your response must be concise. 0.88. What is the ratio of the Revenue generated (in %) of Czech Republic in 1996 to that in 2002?
Provide a short and direct response. 0.71. What is the ratio of the Revenue generated (in %) in Seychelles in 1996 to that in 2002?
Offer a very short reply. 0.65. What is the ratio of the Revenue generated (in %) of St. Vincent and the Grenadines in 1996 to that in 2002?
Your answer should be compact. 0.9. What is the ratio of the Revenue generated (in %) in Zambia in 1996 to that in 2002?
Your answer should be compact. 0.74. What is the ratio of the Revenue generated (in %) in Czech Republic in 1997 to that in 1998?
Provide a succinct answer. 0.91. What is the ratio of the Revenue generated (in %) in Seychelles in 1997 to that in 1998?
Ensure brevity in your answer.  0.84. What is the ratio of the Revenue generated (in %) of St. Vincent and the Grenadines in 1997 to that in 1998?
Provide a short and direct response. 0.95. What is the ratio of the Revenue generated (in %) in Zambia in 1997 to that in 1998?
Your answer should be compact. 1.24. What is the ratio of the Revenue generated (in %) of Czech Republic in 1997 to that in 1999?
Provide a short and direct response. 0.97. What is the ratio of the Revenue generated (in %) of Seychelles in 1997 to that in 1999?
Ensure brevity in your answer.  0.69. What is the ratio of the Revenue generated (in %) in St. Vincent and the Grenadines in 1997 to that in 1999?
Give a very brief answer. 0.98. What is the ratio of the Revenue generated (in %) in Zambia in 1997 to that in 1999?
Ensure brevity in your answer.  1.24. What is the ratio of the Revenue generated (in %) in Czech Republic in 1997 to that in 2001?
Offer a terse response. 0.69. What is the ratio of the Revenue generated (in %) in Seychelles in 1997 to that in 2001?
Your answer should be compact. 0.62. What is the ratio of the Revenue generated (in %) of St. Vincent and the Grenadines in 1997 to that in 2001?
Offer a terse response. 1. What is the ratio of the Revenue generated (in %) of Zambia in 1997 to that in 2001?
Give a very brief answer. 0.9. What is the ratio of the Revenue generated (in %) in Czech Republic in 1997 to that in 2002?
Ensure brevity in your answer.  0.66. What is the ratio of the Revenue generated (in %) in Seychelles in 1997 to that in 2002?
Your answer should be compact. 0.65. What is the ratio of the Revenue generated (in %) in St. Vincent and the Grenadines in 1997 to that in 2002?
Your answer should be compact. 0.86. What is the ratio of the Revenue generated (in %) of Zambia in 1997 to that in 2002?
Your answer should be very brief. 0.75. What is the ratio of the Revenue generated (in %) of Czech Republic in 1998 to that in 1999?
Provide a succinct answer. 1.06. What is the ratio of the Revenue generated (in %) of Seychelles in 1998 to that in 1999?
Your response must be concise. 0.82. What is the ratio of the Revenue generated (in %) in St. Vincent and the Grenadines in 1998 to that in 1999?
Provide a succinct answer. 1.02. What is the ratio of the Revenue generated (in %) in Zambia in 1998 to that in 1999?
Your answer should be compact. 1. What is the ratio of the Revenue generated (in %) in Czech Republic in 1998 to that in 2001?
Your answer should be very brief. 0.75. What is the ratio of the Revenue generated (in %) in Seychelles in 1998 to that in 2001?
Ensure brevity in your answer.  0.74. What is the ratio of the Revenue generated (in %) of St. Vincent and the Grenadines in 1998 to that in 2001?
Give a very brief answer. 1.04. What is the ratio of the Revenue generated (in %) of Zambia in 1998 to that in 2001?
Your answer should be very brief. 0.72. What is the ratio of the Revenue generated (in %) in Czech Republic in 1998 to that in 2002?
Offer a terse response. 0.72. What is the ratio of the Revenue generated (in %) of Seychelles in 1998 to that in 2002?
Your answer should be very brief. 0.77. What is the ratio of the Revenue generated (in %) of St. Vincent and the Grenadines in 1998 to that in 2002?
Make the answer very short. 0.9. What is the ratio of the Revenue generated (in %) of Zambia in 1998 to that in 2002?
Ensure brevity in your answer.  0.61. What is the ratio of the Revenue generated (in %) of Czech Republic in 1999 to that in 2001?
Give a very brief answer. 0.71. What is the ratio of the Revenue generated (in %) in Seychelles in 1999 to that in 2001?
Your response must be concise. 0.9. What is the ratio of the Revenue generated (in %) in St. Vincent and the Grenadines in 1999 to that in 2001?
Provide a short and direct response. 1.02. What is the ratio of the Revenue generated (in %) of Zambia in 1999 to that in 2001?
Give a very brief answer. 0.72. What is the ratio of the Revenue generated (in %) of Czech Republic in 1999 to that in 2002?
Ensure brevity in your answer.  0.68. What is the ratio of the Revenue generated (in %) in Seychelles in 1999 to that in 2002?
Your answer should be very brief. 0.94. What is the ratio of the Revenue generated (in %) in St. Vincent and the Grenadines in 1999 to that in 2002?
Offer a terse response. 0.88. What is the ratio of the Revenue generated (in %) of Zambia in 1999 to that in 2002?
Your answer should be very brief. 0.61. What is the ratio of the Revenue generated (in %) in Czech Republic in 2001 to that in 2002?
Provide a succinct answer. 0.96. What is the ratio of the Revenue generated (in %) in Seychelles in 2001 to that in 2002?
Your response must be concise. 1.04. What is the ratio of the Revenue generated (in %) of St. Vincent and the Grenadines in 2001 to that in 2002?
Your answer should be compact. 0.87. What is the ratio of the Revenue generated (in %) of Zambia in 2001 to that in 2002?
Your answer should be compact. 0.84. What is the difference between the highest and the second highest Revenue generated (in %) of Czech Republic?
Give a very brief answer. 0.73. What is the difference between the highest and the second highest Revenue generated (in %) of Seychelles?
Make the answer very short. 0.6. What is the difference between the highest and the second highest Revenue generated (in %) in St. Vincent and the Grenadines?
Ensure brevity in your answer.  2.71. What is the difference between the highest and the second highest Revenue generated (in %) in Zambia?
Provide a short and direct response. 6.78. What is the difference between the highest and the lowest Revenue generated (in %) of Czech Republic?
Offer a terse response. 6.88. What is the difference between the highest and the lowest Revenue generated (in %) of Seychelles?
Your answer should be compact. 6.19. What is the difference between the highest and the lowest Revenue generated (in %) of St. Vincent and the Grenadines?
Your answer should be very brief. 3.85. What is the difference between the highest and the lowest Revenue generated (in %) in Zambia?
Provide a short and direct response. 16.72. 